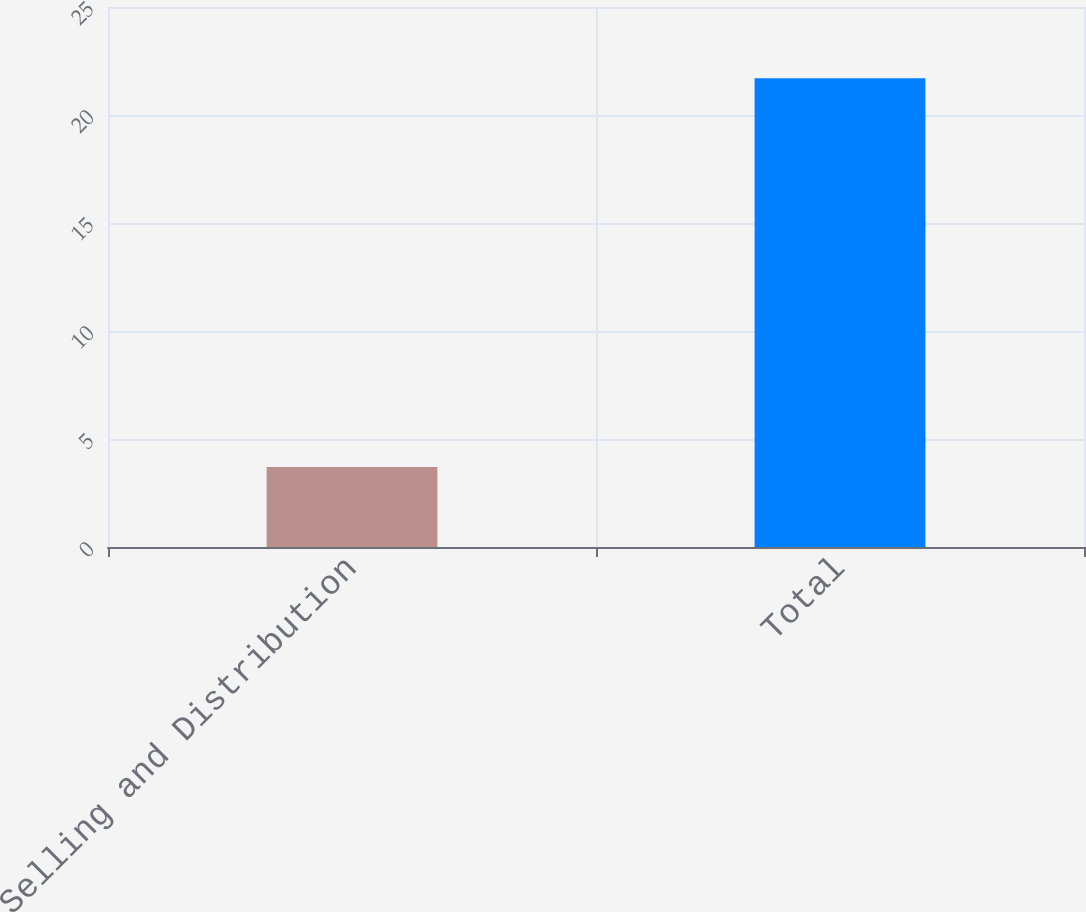Convert chart. <chart><loc_0><loc_0><loc_500><loc_500><bar_chart><fcel>Selling and Distribution<fcel>Total<nl><fcel>3.7<fcel>21.7<nl></chart> 